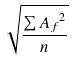<formula> <loc_0><loc_0><loc_500><loc_500>\sqrt { \frac { \sum { A _ { f } } ^ { 2 } } { n } }</formula> 